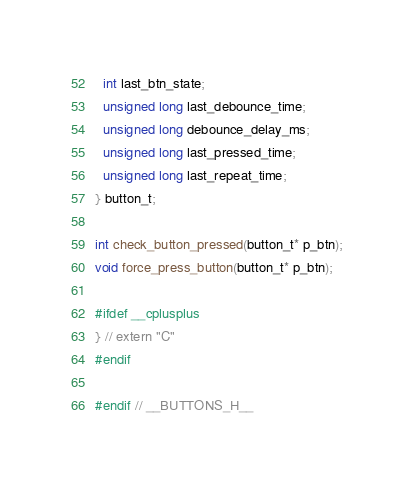<code> <loc_0><loc_0><loc_500><loc_500><_C_>  int last_btn_state;
  unsigned long last_debounce_time;
  unsigned long debounce_delay_ms;
  unsigned long last_pressed_time;
  unsigned long last_repeat_time;
} button_t;

int check_button_pressed(button_t* p_btn);
void force_press_button(button_t* p_btn);

#ifdef __cplusplus
} // extern "C"
#endif
  
#endif // __BUTTONS_H__
</code> 